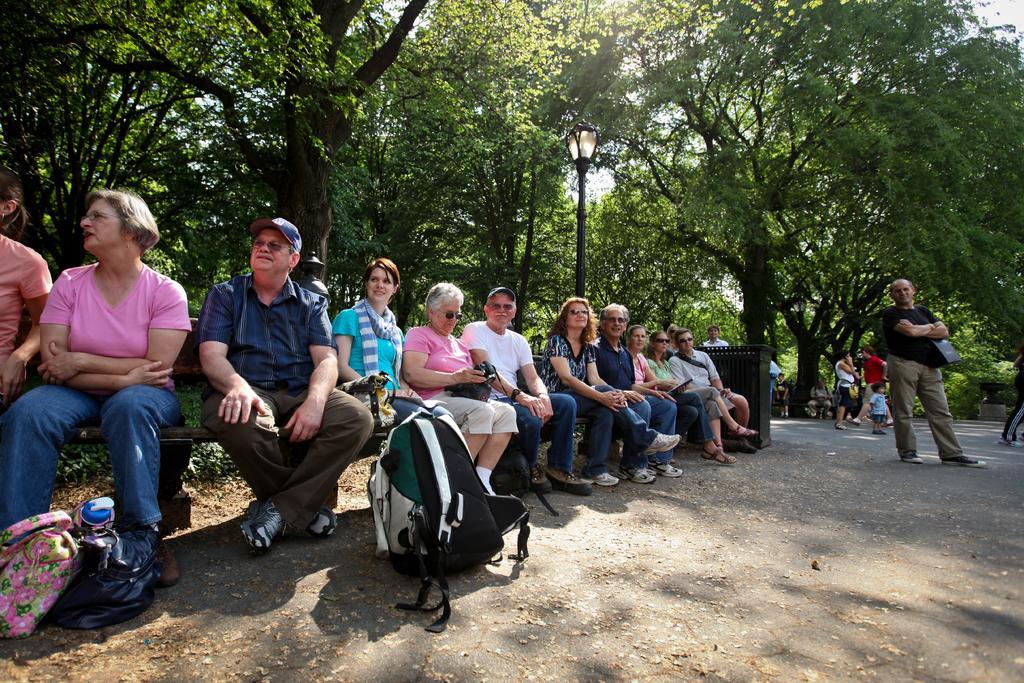How would you summarize this image in a sentence or two? In this image I can see the group of people with different color dresses. I can see few people are sitting and few are standing. I can see few people are wearing the goggles and caps. There are some bags on the road. In the background I can see the light pole, many trees and the sky. 